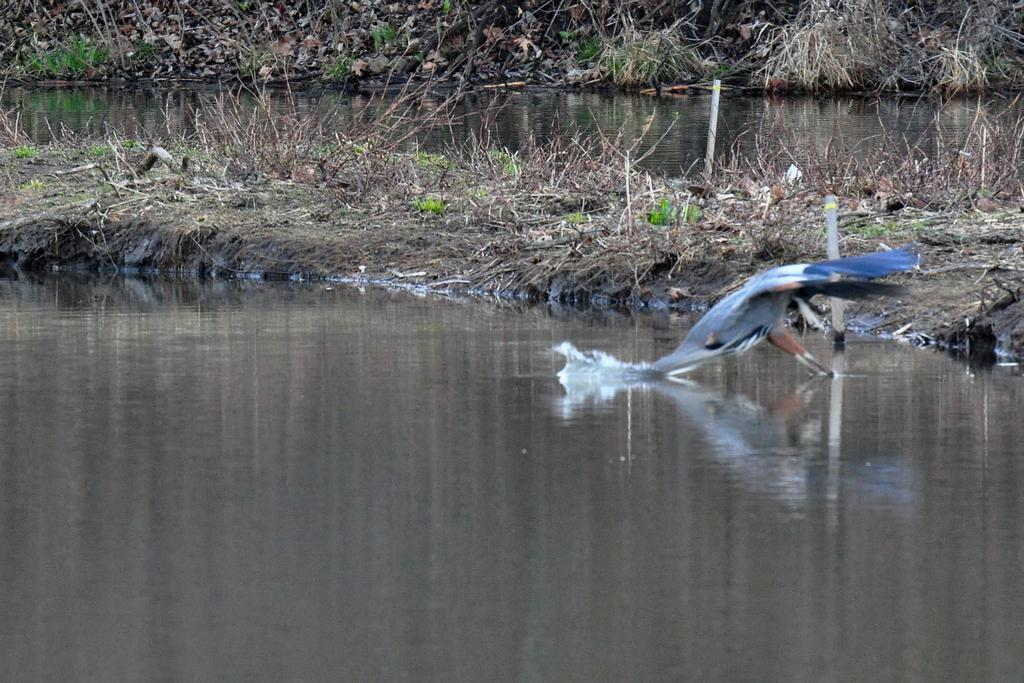What type of body of water is present in the image? There is a lake in the image. Can you describe any animals visible in the image? There is a bird on the right side of the image. What type of vegetation can be seen in the background of the image? There is grass visible in the background of the image. What type of pencil is being used to draw the lake in the image? There is no pencil present in the image, as it is a photograph of a real lake. 